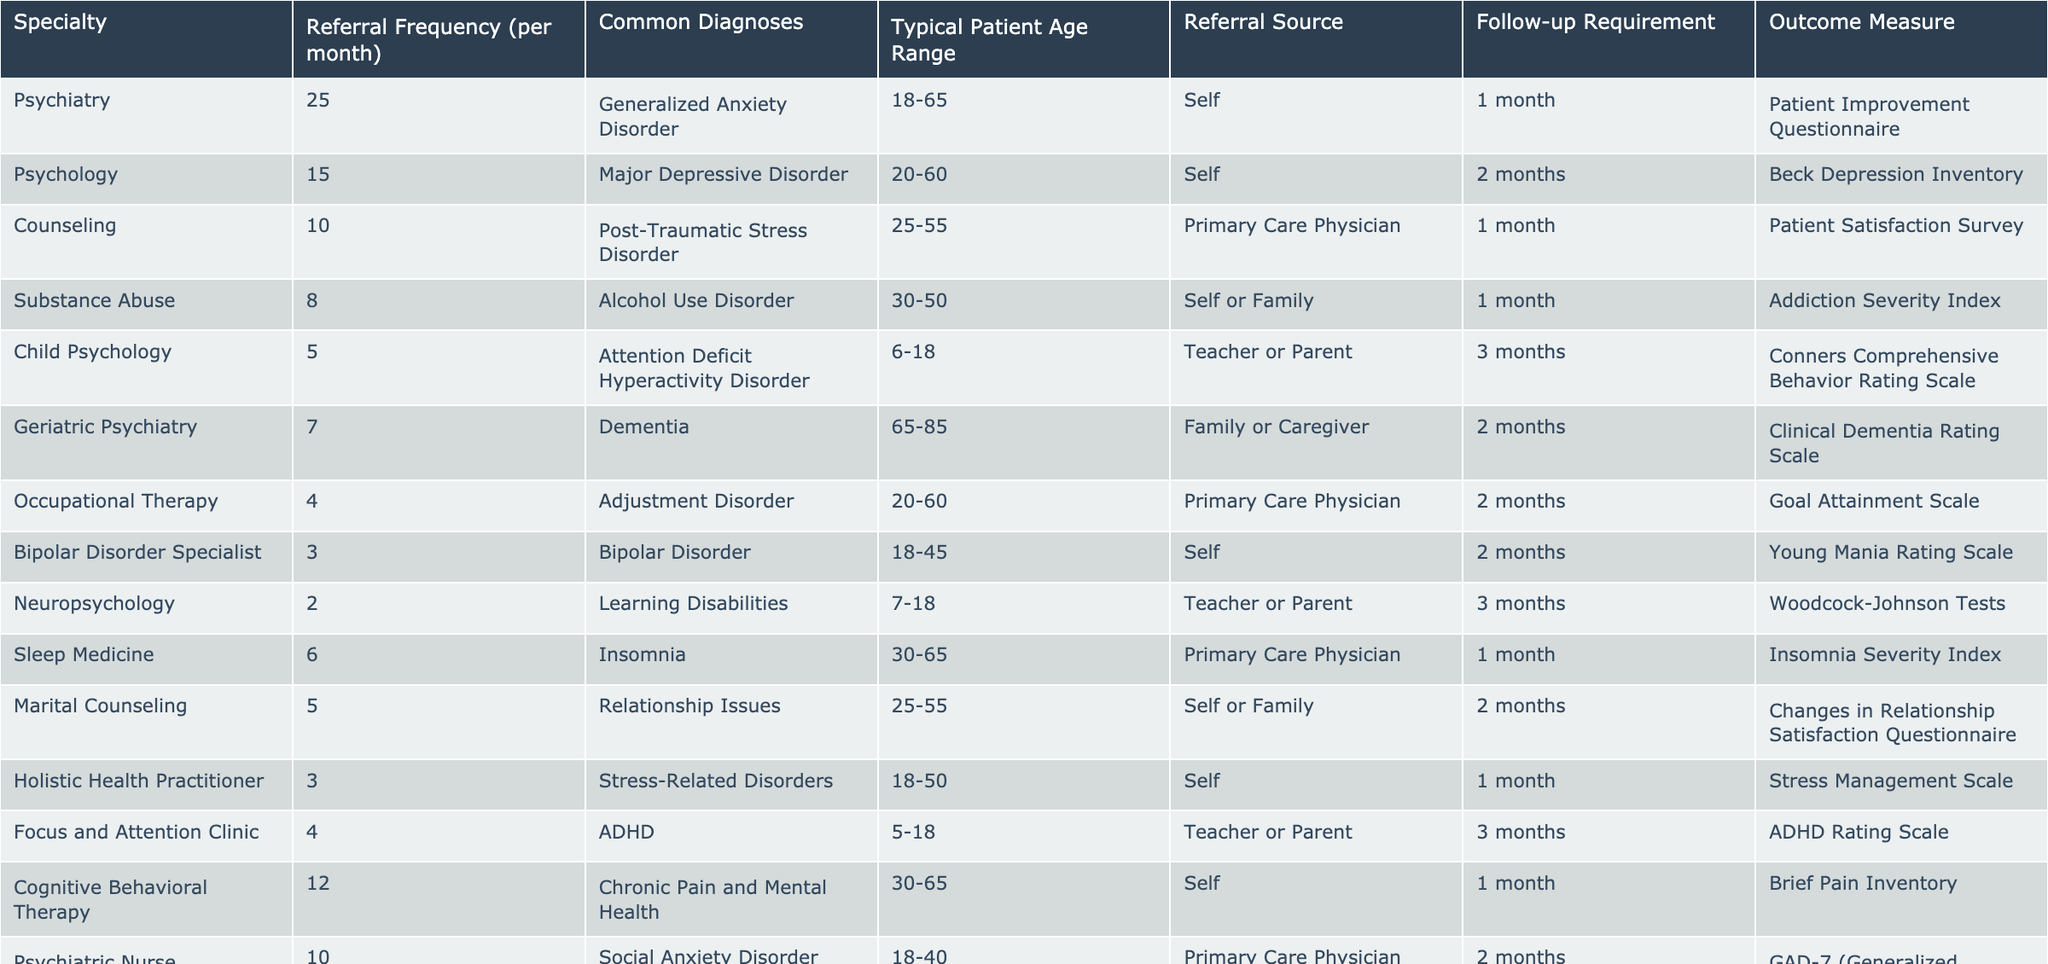What is the most frequently referred specialty? The highest value in the 'Referral Frequency per month' column is 25, which corresponds to the Psychiatry specialty.
Answer: Psychiatry How many referrals are made for Child Psychology per month? The table shows that 5 referrals are made for Child Psychology each month.
Answer: 5 What is the median referral frequency across all specialties? Listing the referral frequencies: 25, 15, 10, 8, 5, 7, 4, 3, 2, 6, 5, 3, 4, 12, 10. Sorting these values gives: 2, 3, 3, 4, 4, 5, 5, 6, 7, 8, 10, 10, 12, 15, 25. There are 15 values, so the median is the 8th value which is 6.
Answer: 6 What percentage of referrals per month are for Substance Abuse? The total referral frequency sums up to 100 (25+15+10+8+5+7+4+3+2+6+5+3+4+12+10). The referrals for Substance Abuse are 8, so the percentage is (8/100)*100% = 8%.
Answer: 8% Is the typical patient age range for Marital Counseling the same as that for Counseling? The typical age range for Marital Counseling is 25-55 and for Counseling is also 25-55, so they are the same.
Answer: Yes Which specialty requires the longest follow-up period after referral and what is that period? The Child Psychology specialty has the longest follow-up period of 3 months, as indicated in the table.
Answer: 3 months What is the average referral frequency for specialties that require a 2-month follow-up? The specialties requiring 2-month follow-ups are Psychology (15), Geriatric Psychiatry (7), Occupational Therapy (4), Bipolar Disorder Specialist (3), Psychiatric Nurse Practitioner (10). The average is (15 + 7 + 4 + 3 + 10) / 5 = 39 / 5 = 7.8.
Answer: 7.8 What types of referral sources are noted for Generalized Anxiety Disorder? The referral sources for Generalized Anxiety Disorder include 'Self' as noted under the Psychiatry specialty in the table.
Answer: Self Are there more referrals for Cognitive Behavioral Therapy or for Sleep Medicine? The table shows that there are 12 referrals for Cognitive Behavioral Therapy, compared to 6 for Sleep Medicine. Since 12 is greater than 6, there are more for Cognitive Behavioral Therapy.
Answer: Cognitive Behavioral Therapy For which diagnosis is the most common follow-up requirement and what is it? The most common follow-up requirement, based on frequency, is 1 month, for several specialties including Psychiatry, Counseling, Substance Abuse, Sleep Medicine, and Cognitive Behavioral Therapy.
Answer: 1 month 